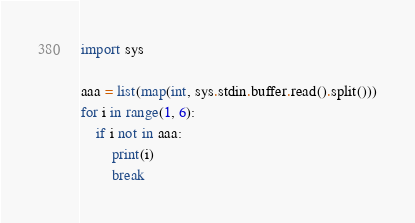Convert code to text. <code><loc_0><loc_0><loc_500><loc_500><_Python_>import sys

aaa = list(map(int, sys.stdin.buffer.read().split()))
for i in range(1, 6):
    if i not in aaa:
        print(i)
        break
</code> 